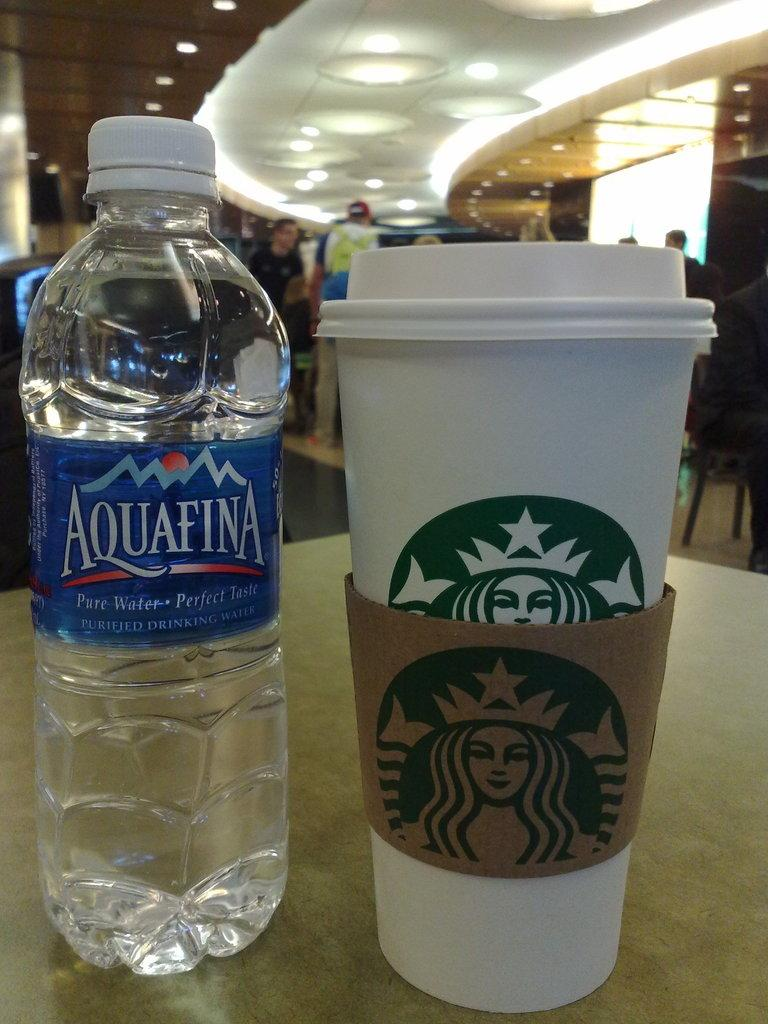What is on the table in the image? There is a bottle and a cup on the table. What is written on the bottle? The word "Aquafina" is written on the bottle. Can you see the face of the person who made a profit from the plastic bottle in the image? There is no face or person visible in the image, and the concept of profit is not mentioned or depicted. 